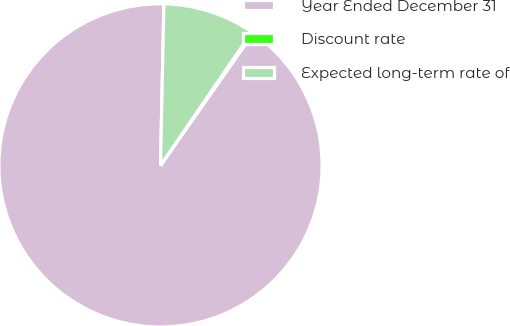Convert chart to OTSL. <chart><loc_0><loc_0><loc_500><loc_500><pie_chart><fcel>Year Ended December 31<fcel>Discount rate<fcel>Expected long-term rate of<nl><fcel>90.6%<fcel>0.18%<fcel>9.22%<nl></chart> 